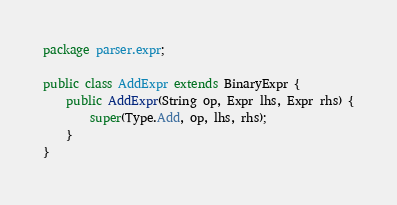<code> <loc_0><loc_0><loc_500><loc_500><_Java_>package parser.expr;

public class AddExpr extends BinaryExpr {
    public AddExpr(String op, Expr lhs, Expr rhs) {
        super(Type.Add, op, lhs, rhs);
    }
}
</code> 